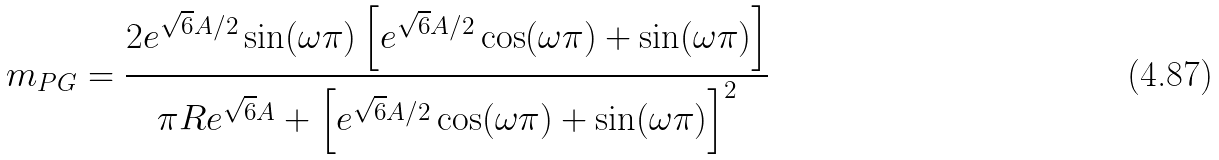<formula> <loc_0><loc_0><loc_500><loc_500>m _ { P G } = \frac { 2 e ^ { \sqrt { 6 } A / 2 } \sin ( \omega \pi ) \left [ e ^ { \sqrt { 6 } A / 2 } \cos ( \omega \pi ) + \sin ( \omega \pi ) \right ] } { \pi R e ^ { \sqrt { 6 } A } + \left [ e ^ { \sqrt { 6 } A / 2 } \cos ( \omega \pi ) + \sin ( \omega \pi ) \right ] ^ { 2 } }</formula> 